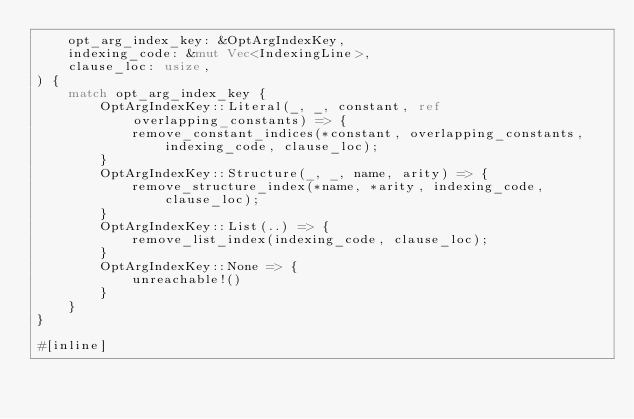<code> <loc_0><loc_0><loc_500><loc_500><_Rust_>    opt_arg_index_key: &OptArgIndexKey,
    indexing_code: &mut Vec<IndexingLine>,
    clause_loc: usize,
) {
    match opt_arg_index_key {
        OptArgIndexKey::Literal(_, _, constant, ref overlapping_constants) => {
            remove_constant_indices(*constant, overlapping_constants, indexing_code, clause_loc);
        }
        OptArgIndexKey::Structure(_, _, name, arity) => {
            remove_structure_index(*name, *arity, indexing_code, clause_loc);
        }
        OptArgIndexKey::List(..) => {
            remove_list_index(indexing_code, clause_loc);
        }
        OptArgIndexKey::None => {
            unreachable!()
        }
    }
}

#[inline]</code> 